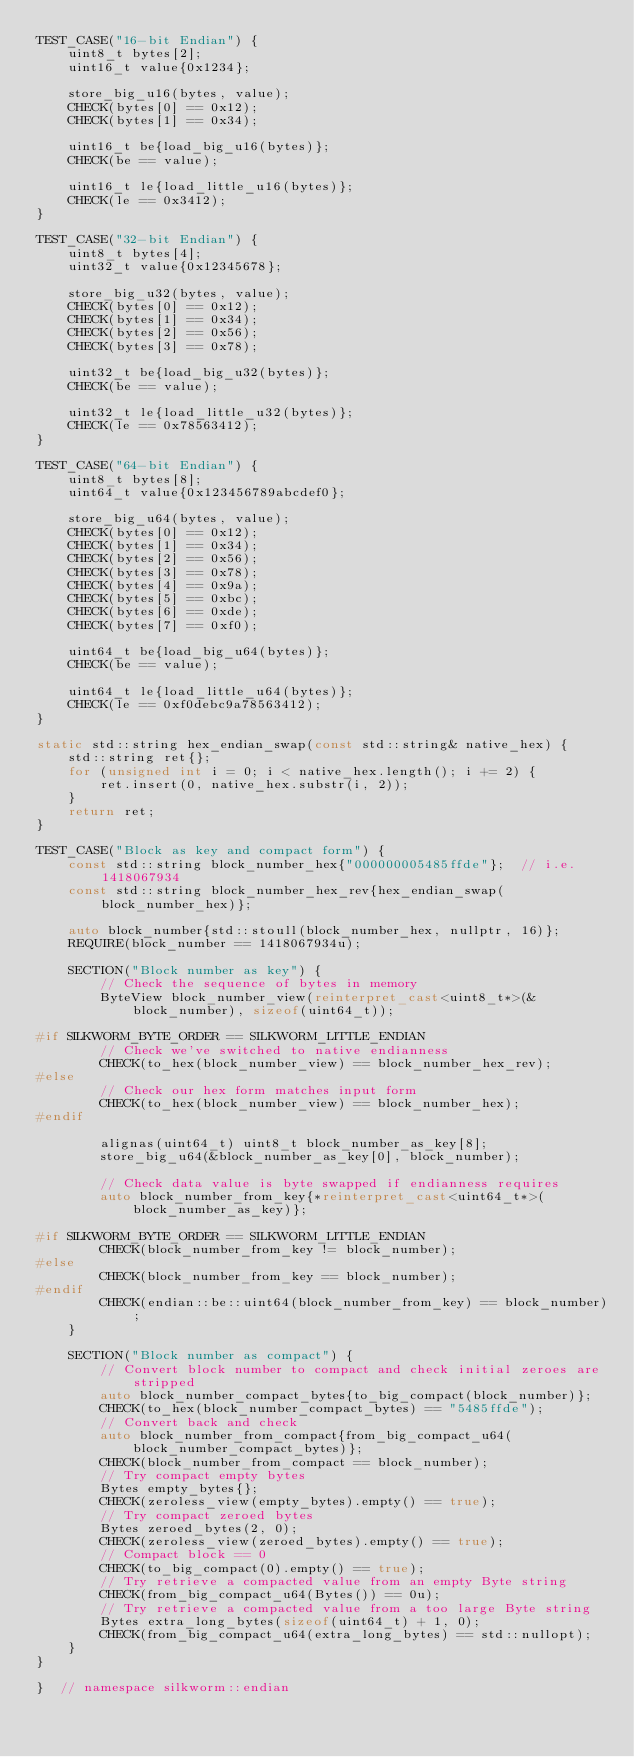Convert code to text. <code><loc_0><loc_0><loc_500><loc_500><_C++_>TEST_CASE("16-bit Endian") {
    uint8_t bytes[2];
    uint16_t value{0x1234};

    store_big_u16(bytes, value);
    CHECK(bytes[0] == 0x12);
    CHECK(bytes[1] == 0x34);

    uint16_t be{load_big_u16(bytes)};
    CHECK(be == value);

    uint16_t le{load_little_u16(bytes)};
    CHECK(le == 0x3412);
}

TEST_CASE("32-bit Endian") {
    uint8_t bytes[4];
    uint32_t value{0x12345678};

    store_big_u32(bytes, value);
    CHECK(bytes[0] == 0x12);
    CHECK(bytes[1] == 0x34);
    CHECK(bytes[2] == 0x56);
    CHECK(bytes[3] == 0x78);

    uint32_t be{load_big_u32(bytes)};
    CHECK(be == value);

    uint32_t le{load_little_u32(bytes)};
    CHECK(le == 0x78563412);
}

TEST_CASE("64-bit Endian") {
    uint8_t bytes[8];
    uint64_t value{0x123456789abcdef0};

    store_big_u64(bytes, value);
    CHECK(bytes[0] == 0x12);
    CHECK(bytes[1] == 0x34);
    CHECK(bytes[2] == 0x56);
    CHECK(bytes[3] == 0x78);
    CHECK(bytes[4] == 0x9a);
    CHECK(bytes[5] == 0xbc);
    CHECK(bytes[6] == 0xde);
    CHECK(bytes[7] == 0xf0);

    uint64_t be{load_big_u64(bytes)};
    CHECK(be == value);

    uint64_t le{load_little_u64(bytes)};
    CHECK(le == 0xf0debc9a78563412);
}

static std::string hex_endian_swap(const std::string& native_hex) {
    std::string ret{};
    for (unsigned int i = 0; i < native_hex.length(); i += 2) {
        ret.insert(0, native_hex.substr(i, 2));
    }
    return ret;
}

TEST_CASE("Block as key and compact form") {
    const std::string block_number_hex{"000000005485ffde"};  // i.e. 1418067934
    const std::string block_number_hex_rev{hex_endian_swap(block_number_hex)};

    auto block_number{std::stoull(block_number_hex, nullptr, 16)};
    REQUIRE(block_number == 1418067934u);

    SECTION("Block number as key") {
        // Check the sequence of bytes in memory
        ByteView block_number_view(reinterpret_cast<uint8_t*>(&block_number), sizeof(uint64_t));

#if SILKWORM_BYTE_ORDER == SILKWORM_LITTLE_ENDIAN
        // Check we've switched to native endianness
        CHECK(to_hex(block_number_view) == block_number_hex_rev);
#else
        // Check our hex form matches input form
        CHECK(to_hex(block_number_view) == block_number_hex);
#endif

        alignas(uint64_t) uint8_t block_number_as_key[8];
        store_big_u64(&block_number_as_key[0], block_number);

        // Check data value is byte swapped if endianness requires
        auto block_number_from_key{*reinterpret_cast<uint64_t*>(block_number_as_key)};

#if SILKWORM_BYTE_ORDER == SILKWORM_LITTLE_ENDIAN
        CHECK(block_number_from_key != block_number);
#else
        CHECK(block_number_from_key == block_number);
#endif
        CHECK(endian::be::uint64(block_number_from_key) == block_number);
    }

    SECTION("Block number as compact") {
        // Convert block number to compact and check initial zeroes are stripped
        auto block_number_compact_bytes{to_big_compact(block_number)};
        CHECK(to_hex(block_number_compact_bytes) == "5485ffde");
        // Convert back and check
        auto block_number_from_compact{from_big_compact_u64(block_number_compact_bytes)};
        CHECK(block_number_from_compact == block_number);
        // Try compact empty bytes
        Bytes empty_bytes{};
        CHECK(zeroless_view(empty_bytes).empty() == true);
        // Try compact zeroed bytes
        Bytes zeroed_bytes(2, 0);
        CHECK(zeroless_view(zeroed_bytes).empty() == true);
        // Compact block == 0
        CHECK(to_big_compact(0).empty() == true);
        // Try retrieve a compacted value from an empty Byte string
        CHECK(from_big_compact_u64(Bytes()) == 0u);
        // Try retrieve a compacted value from a too large Byte string
        Bytes extra_long_bytes(sizeof(uint64_t) + 1, 0);
        CHECK(from_big_compact_u64(extra_long_bytes) == std::nullopt);
    }
}

}  // namespace silkworm::endian
</code> 